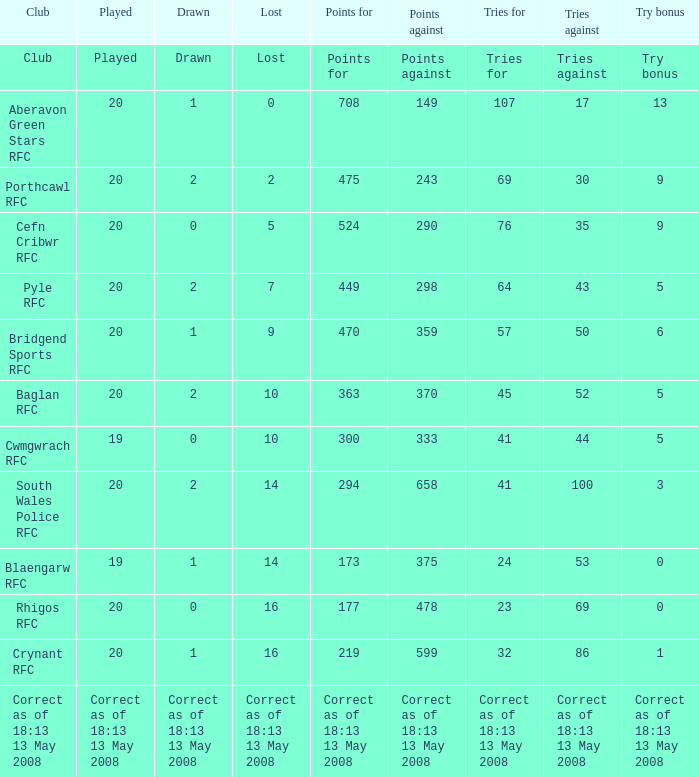What is the tries against when the points are 475? 30.0. 